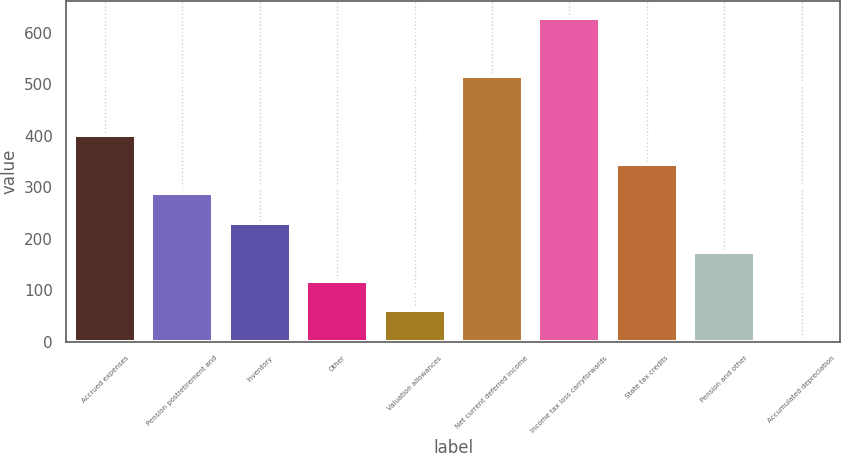Convert chart to OTSL. <chart><loc_0><loc_0><loc_500><loc_500><bar_chart><fcel>Accrued expenses<fcel>Pension postretirement and<fcel>Inventory<fcel>Other<fcel>Valuation allowances<fcel>Net current deferred income<fcel>Income tax loss carryforwards<fcel>State tax credits<fcel>Pension and other<fcel>Accumulated depreciation<nl><fcel>402.14<fcel>288.3<fcel>231.38<fcel>117.54<fcel>60.62<fcel>515.98<fcel>629.82<fcel>345.22<fcel>174.46<fcel>3.7<nl></chart> 